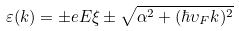Convert formula to latex. <formula><loc_0><loc_0><loc_500><loc_500>\varepsilon ( k ) = \pm e E \xi \pm \sqrt { \alpha ^ { 2 } + ( \hbar { \upsilon } _ { F } k ) ^ { 2 } }</formula> 